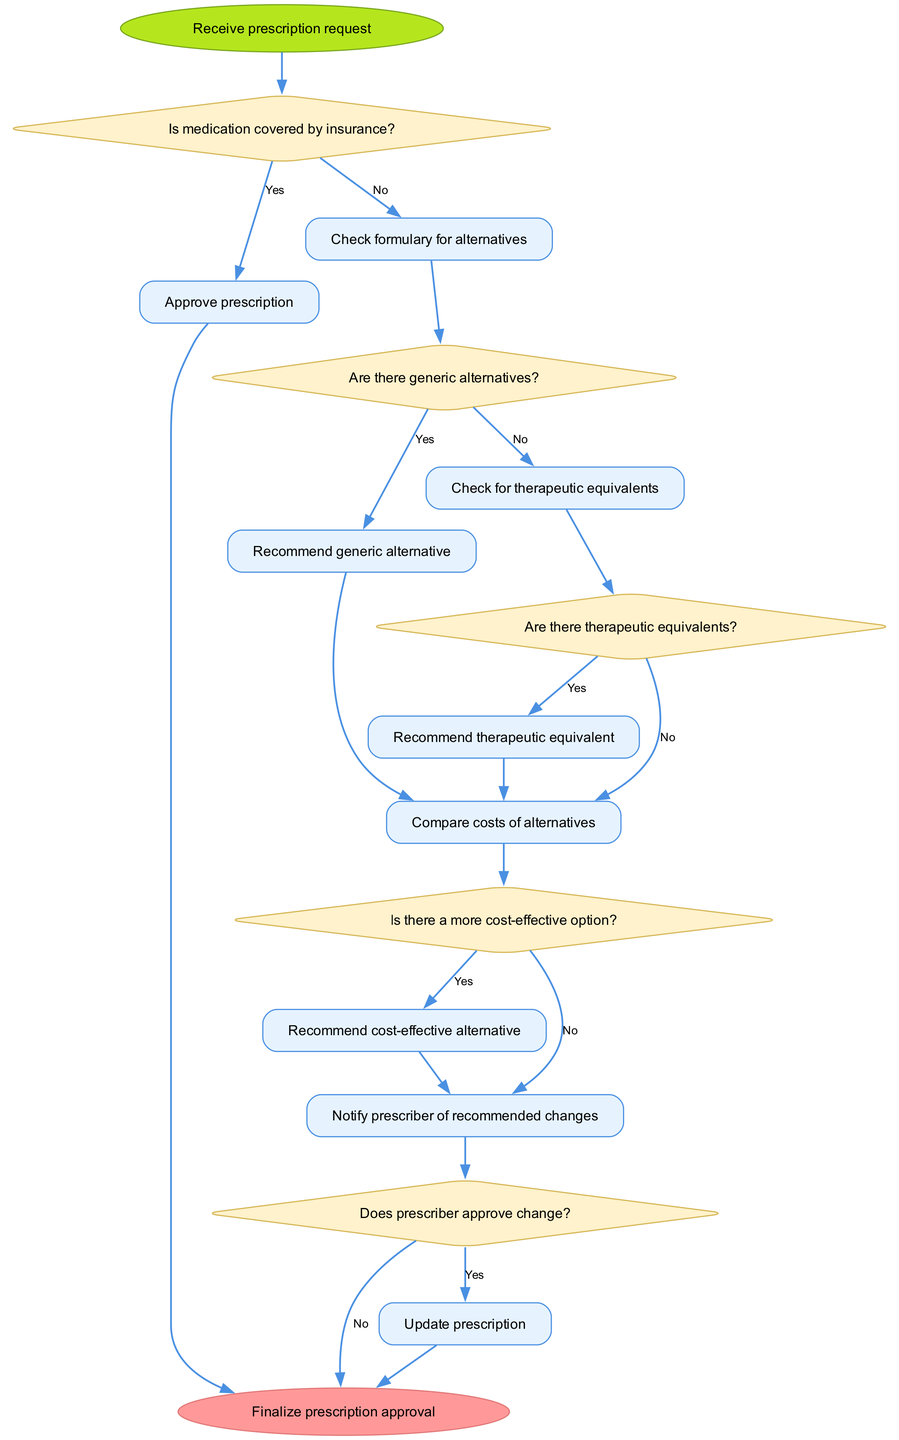What is the first step in the algorithm? The first step in the algorithm, as indicated in the diagram, is to "Receive prescription request." This is represented as the starting node in the flowchart.
Answer: Receive prescription request What type of node is used for decision points? Decision points are represented using diamond-shaped nodes in the flowchart, which typically indicate where a choice must be made.
Answer: Diamond How many process nodes are there in the diagram? The diagram contains nine process nodes, each indicating an action taken in the algorithm. Counting these nodes gives the result.
Answer: Nine What is the outcome if the medication is covered by insurance? If the medication is covered by insurance, the process flows to "Approve prescription," which indicates that the prescription gets authorized.
Answer: Approve prescription What happens if there are no generic alternatives? If there are no generic alternatives, the algorithm proceeds to check for therapeutic equivalents, as indicated in the flowchart.
Answer: Check for therapeutic equivalents What is the last step before finalizing prescription approval? The last step before finalizing prescription approval is "Update prescription," which occurs after the prescriber approves any changes recommended during the process.
Answer: Update prescription What happens if there is a more cost-effective option available? If a more cost-effective option is available, the process will lead to "Recommend cost-effective alternative," indicating that a cheaper option will be suggested.
Answer: Recommend cost-effective alternative How many decision points are present in the flowchart? The flowchart has five decision points, each indicated by a diamond shape where a choice must be made based on previous steps in the process.
Answer: Five What does the algorithm do if the prescriber does not approve the recommended change? If the prescriber does not approve the recommended change, the algorithm ends at that point without updating the prescription, as indicated by the flowchart.
Answer: End 